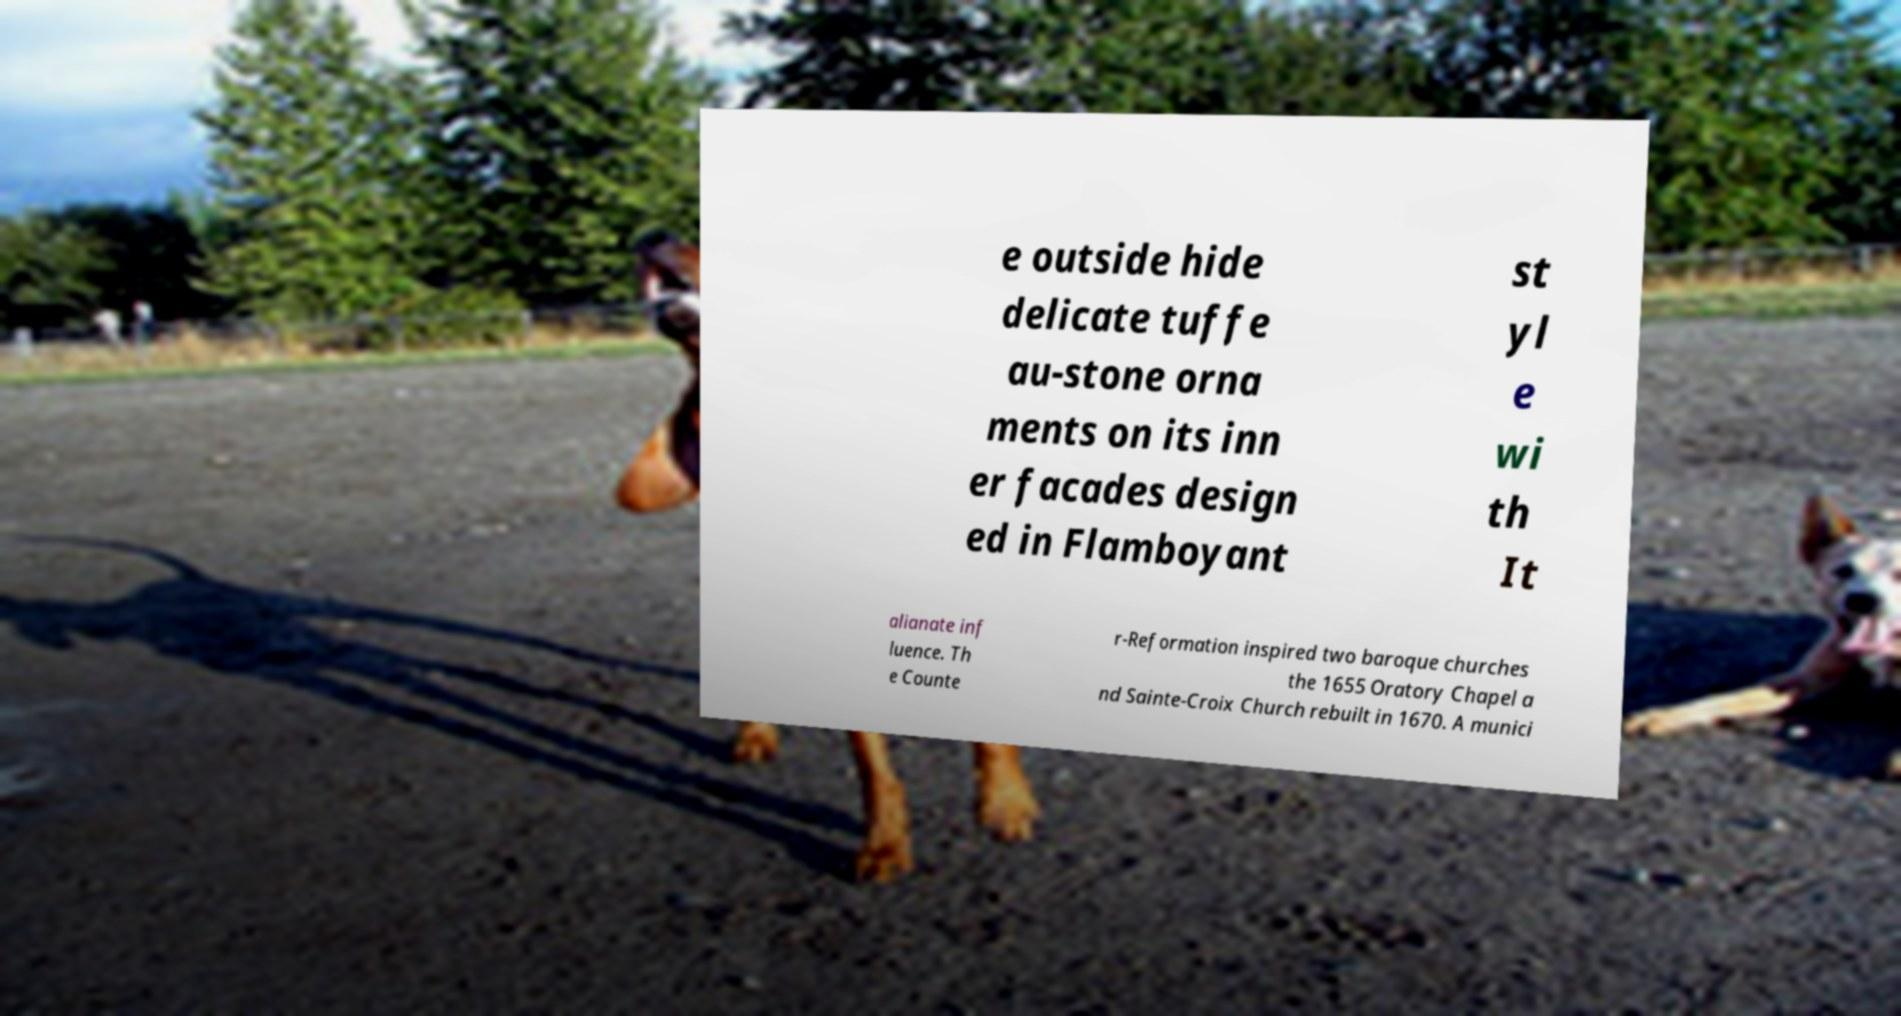What messages or text are displayed in this image? I need them in a readable, typed format. e outside hide delicate tuffe au-stone orna ments on its inn er facades design ed in Flamboyant st yl e wi th It alianate inf luence. Th e Counte r-Reformation inspired two baroque churches the 1655 Oratory Chapel a nd Sainte-Croix Church rebuilt in 1670. A munici 